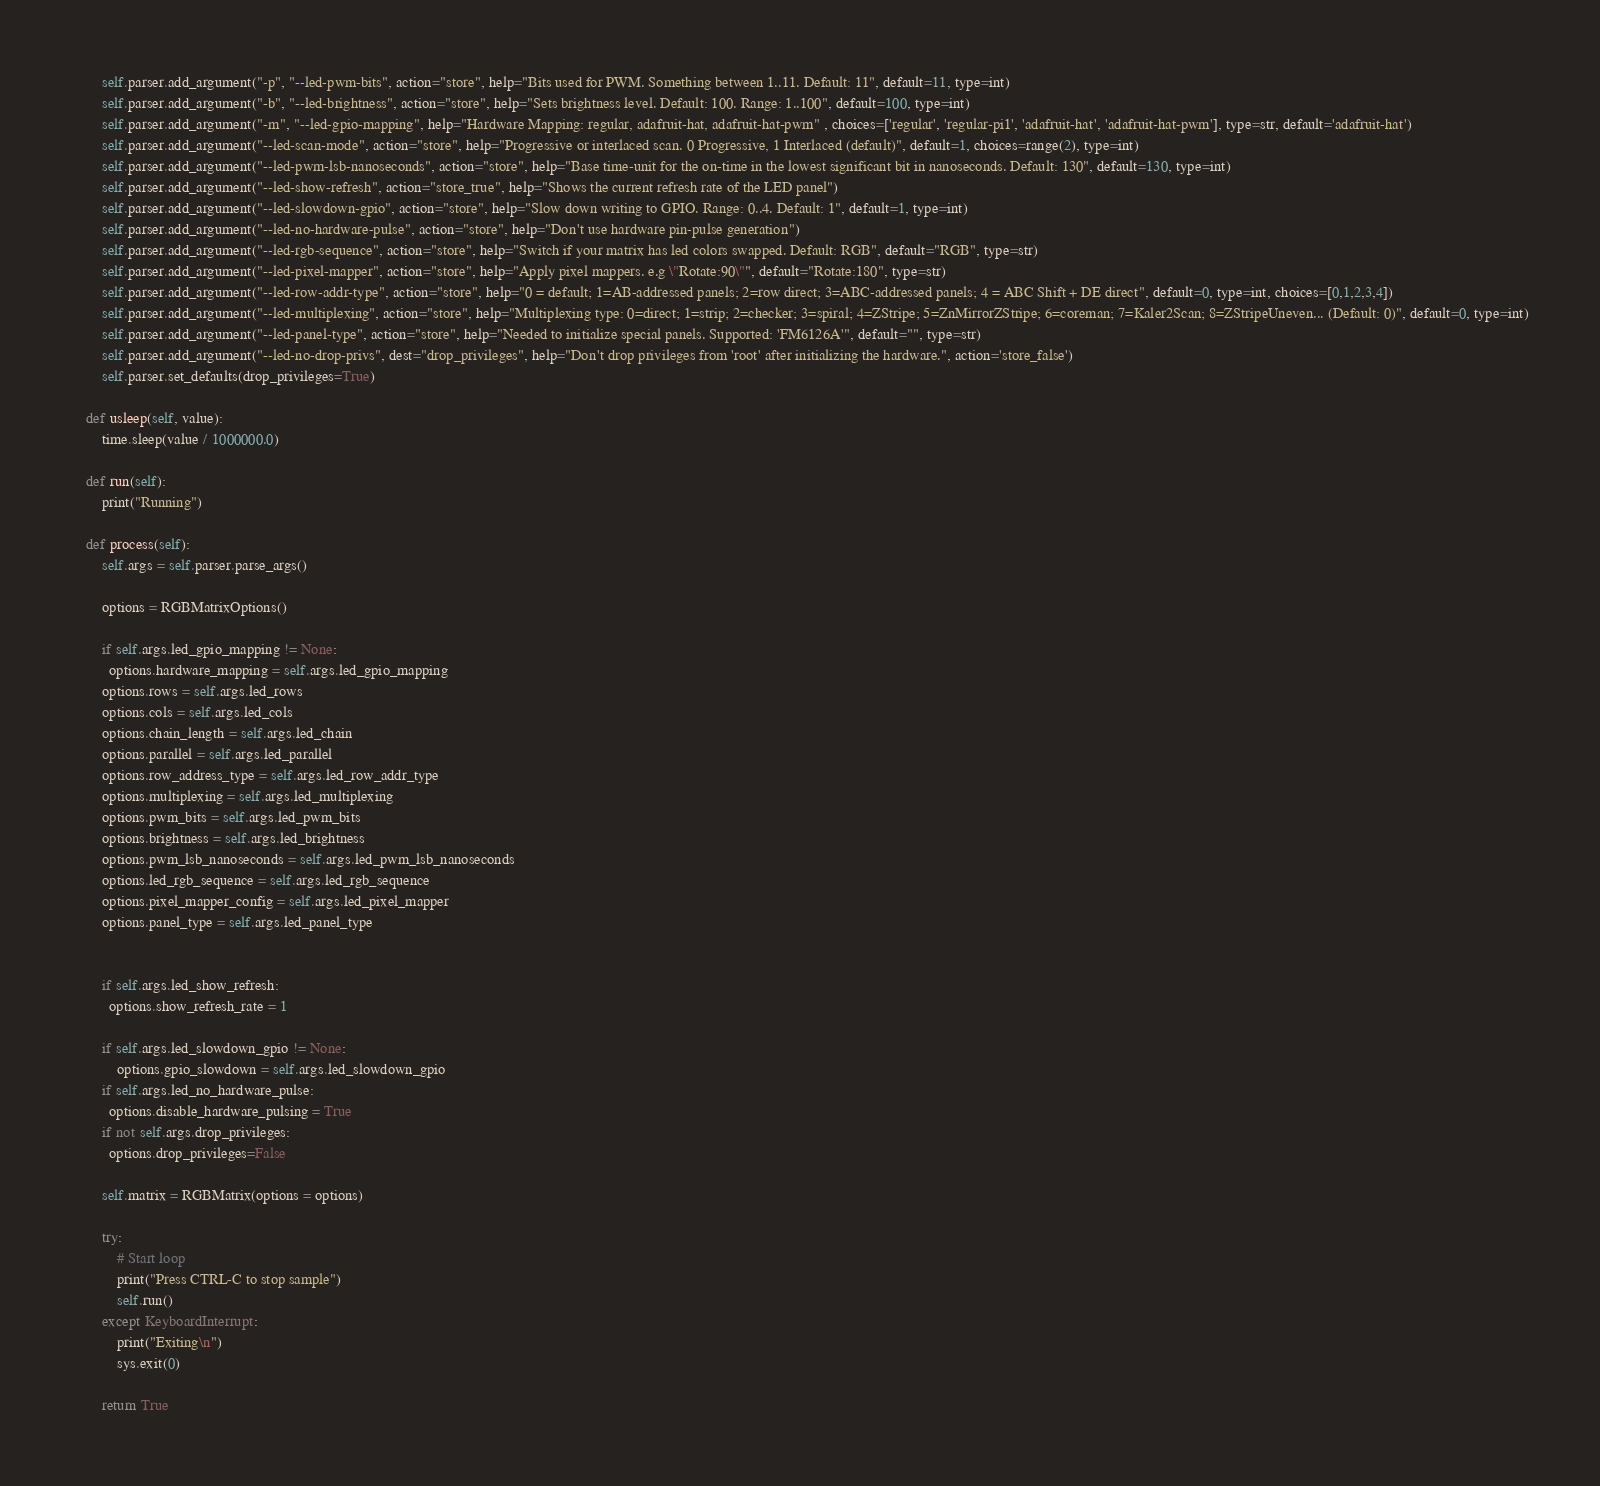<code> <loc_0><loc_0><loc_500><loc_500><_Python_>        self.parser.add_argument("-p", "--led-pwm-bits", action="store", help="Bits used for PWM. Something between 1..11. Default: 11", default=11, type=int)
        self.parser.add_argument("-b", "--led-brightness", action="store", help="Sets brightness level. Default: 100. Range: 1..100", default=100, type=int)
        self.parser.add_argument("-m", "--led-gpio-mapping", help="Hardware Mapping: regular, adafruit-hat, adafruit-hat-pwm" , choices=['regular', 'regular-pi1', 'adafruit-hat', 'adafruit-hat-pwm'], type=str, default='adafruit-hat')
        self.parser.add_argument("--led-scan-mode", action="store", help="Progressive or interlaced scan. 0 Progressive, 1 Interlaced (default)", default=1, choices=range(2), type=int)
        self.parser.add_argument("--led-pwm-lsb-nanoseconds", action="store", help="Base time-unit for the on-time in the lowest significant bit in nanoseconds. Default: 130", default=130, type=int)
        self.parser.add_argument("--led-show-refresh", action="store_true", help="Shows the current refresh rate of the LED panel")
        self.parser.add_argument("--led-slowdown-gpio", action="store", help="Slow down writing to GPIO. Range: 0..4. Default: 1", default=1, type=int)
        self.parser.add_argument("--led-no-hardware-pulse", action="store", help="Don't use hardware pin-pulse generation")
        self.parser.add_argument("--led-rgb-sequence", action="store", help="Switch if your matrix has led colors swapped. Default: RGB", default="RGB", type=str)
        self.parser.add_argument("--led-pixel-mapper", action="store", help="Apply pixel mappers. e.g \"Rotate:90\"", default="Rotate:180", type=str)
        self.parser.add_argument("--led-row-addr-type", action="store", help="0 = default; 1=AB-addressed panels; 2=row direct; 3=ABC-addressed panels; 4 = ABC Shift + DE direct", default=0, type=int, choices=[0,1,2,3,4])
        self.parser.add_argument("--led-multiplexing", action="store", help="Multiplexing type: 0=direct; 1=strip; 2=checker; 3=spiral; 4=ZStripe; 5=ZnMirrorZStripe; 6=coreman; 7=Kaler2Scan; 8=ZStripeUneven... (Default: 0)", default=0, type=int)
        self.parser.add_argument("--led-panel-type", action="store", help="Needed to initialize special panels. Supported: 'FM6126A'", default="", type=str)
        self.parser.add_argument("--led-no-drop-privs", dest="drop_privileges", help="Don't drop privileges from 'root' after initializing the hardware.", action='store_false')
        self.parser.set_defaults(drop_privileges=True)

    def usleep(self, value):
        time.sleep(value / 1000000.0)

    def run(self):
        print("Running")

    def process(self):
        self.args = self.parser.parse_args()

        options = RGBMatrixOptions()

        if self.args.led_gpio_mapping != None:
          options.hardware_mapping = self.args.led_gpio_mapping
        options.rows = self.args.led_rows
        options.cols = self.args.led_cols
        options.chain_length = self.args.led_chain
        options.parallel = self.args.led_parallel
        options.row_address_type = self.args.led_row_addr_type
        options.multiplexing = self.args.led_multiplexing
        options.pwm_bits = self.args.led_pwm_bits
        options.brightness = self.args.led_brightness
        options.pwm_lsb_nanoseconds = self.args.led_pwm_lsb_nanoseconds
        options.led_rgb_sequence = self.args.led_rgb_sequence
        options.pixel_mapper_config = self.args.led_pixel_mapper
        options.panel_type = self.args.led_panel_type


        if self.args.led_show_refresh:
          options.show_refresh_rate = 1

        if self.args.led_slowdown_gpio != None:
            options.gpio_slowdown = self.args.led_slowdown_gpio
        if self.args.led_no_hardware_pulse:
          options.disable_hardware_pulsing = True
        if not self.args.drop_privileges:
          options.drop_privileges=False

        self.matrix = RGBMatrix(options = options)

        try:
            # Start loop
            print("Press CTRL-C to stop sample")
            self.run()
        except KeyboardInterrupt:
            print("Exiting\n")
            sys.exit(0)

        return True
</code> 